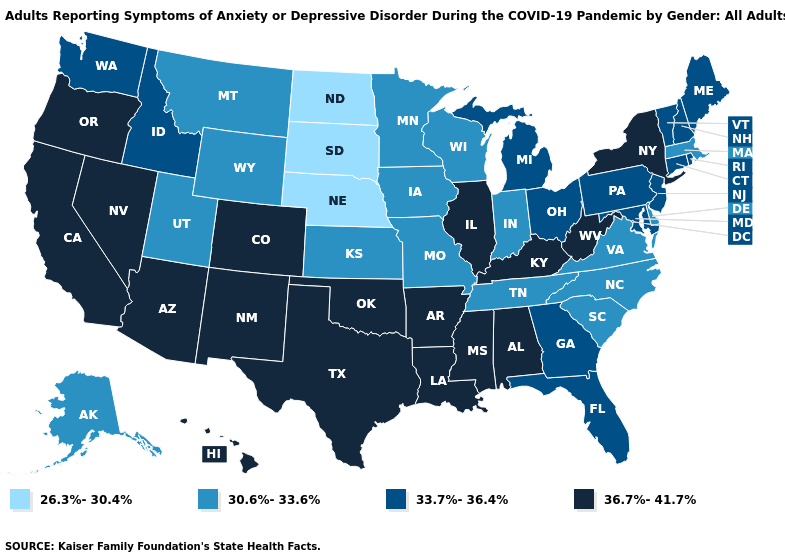What is the highest value in states that border Arizona?
Write a very short answer. 36.7%-41.7%. Does New York have the same value as South Dakota?
Quick response, please. No. Name the states that have a value in the range 36.7%-41.7%?
Be succinct. Alabama, Arizona, Arkansas, California, Colorado, Hawaii, Illinois, Kentucky, Louisiana, Mississippi, Nevada, New Mexico, New York, Oklahoma, Oregon, Texas, West Virginia. What is the value of Maine?
Be succinct. 33.7%-36.4%. Name the states that have a value in the range 30.6%-33.6%?
Write a very short answer. Alaska, Delaware, Indiana, Iowa, Kansas, Massachusetts, Minnesota, Missouri, Montana, North Carolina, South Carolina, Tennessee, Utah, Virginia, Wisconsin, Wyoming. Is the legend a continuous bar?
Write a very short answer. No. Name the states that have a value in the range 36.7%-41.7%?
Concise answer only. Alabama, Arizona, Arkansas, California, Colorado, Hawaii, Illinois, Kentucky, Louisiana, Mississippi, Nevada, New Mexico, New York, Oklahoma, Oregon, Texas, West Virginia. What is the lowest value in the MidWest?
Be succinct. 26.3%-30.4%. Does the map have missing data?
Give a very brief answer. No. Name the states that have a value in the range 36.7%-41.7%?
Be succinct. Alabama, Arizona, Arkansas, California, Colorado, Hawaii, Illinois, Kentucky, Louisiana, Mississippi, Nevada, New Mexico, New York, Oklahoma, Oregon, Texas, West Virginia. Name the states that have a value in the range 36.7%-41.7%?
Quick response, please. Alabama, Arizona, Arkansas, California, Colorado, Hawaii, Illinois, Kentucky, Louisiana, Mississippi, Nevada, New Mexico, New York, Oklahoma, Oregon, Texas, West Virginia. Does Minnesota have a lower value than South Dakota?
Concise answer only. No. What is the value of Nevada?
Keep it brief. 36.7%-41.7%. What is the value of Virginia?
Short answer required. 30.6%-33.6%. What is the value of Delaware?
Concise answer only. 30.6%-33.6%. 